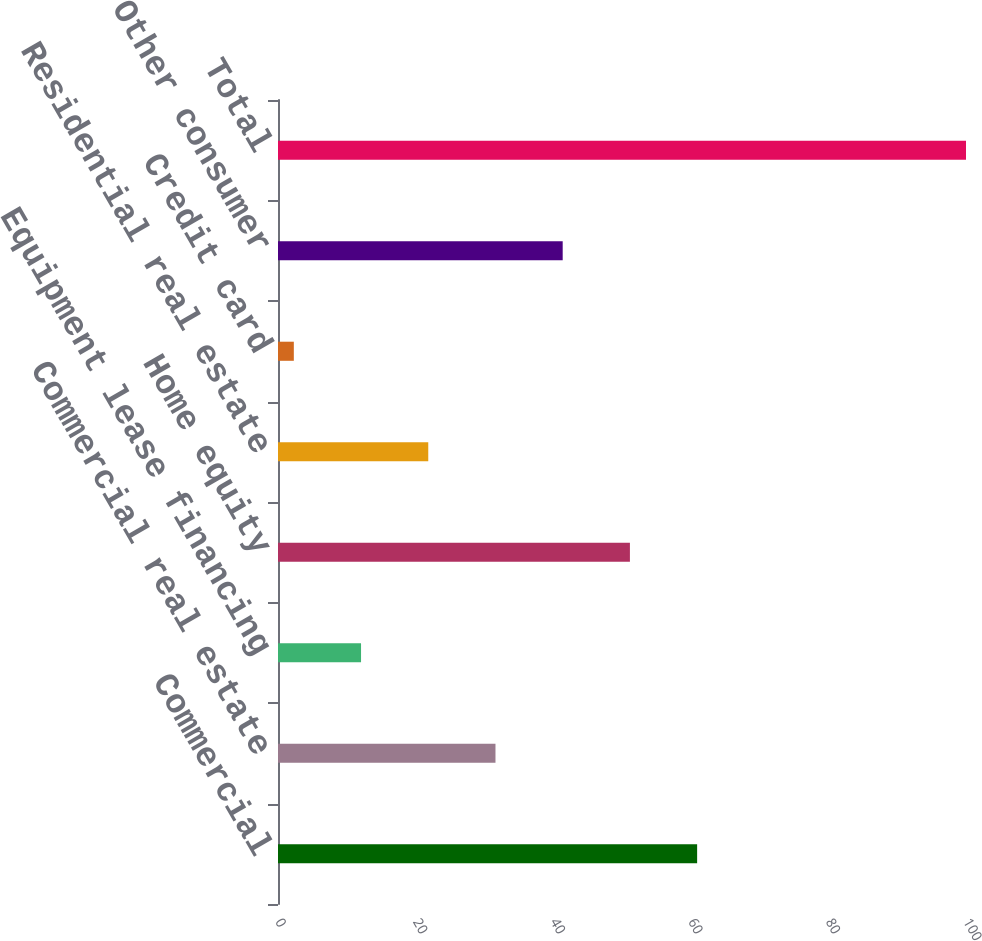<chart> <loc_0><loc_0><loc_500><loc_500><bar_chart><fcel>Commercial<fcel>Commercial real estate<fcel>Equipment lease financing<fcel>Home equity<fcel>Residential real estate<fcel>Credit card<fcel>Other consumer<fcel>Total<nl><fcel>60.92<fcel>31.61<fcel>12.07<fcel>51.15<fcel>21.84<fcel>2.3<fcel>41.38<fcel>100<nl></chart> 